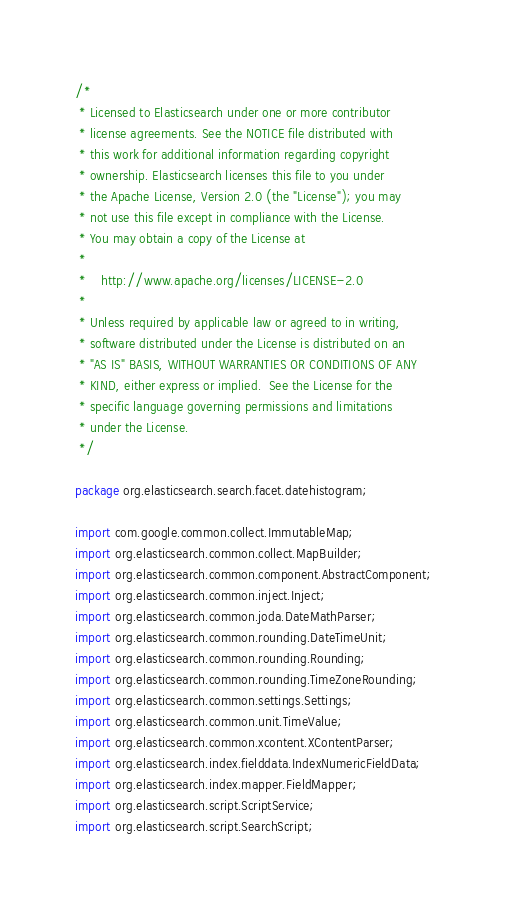Convert code to text. <code><loc_0><loc_0><loc_500><loc_500><_Java_>/*
 * Licensed to Elasticsearch under one or more contributor
 * license agreements. See the NOTICE file distributed with
 * this work for additional information regarding copyright
 * ownership. Elasticsearch licenses this file to you under
 * the Apache License, Version 2.0 (the "License"); you may
 * not use this file except in compliance with the License.
 * You may obtain a copy of the License at
 *
 *    http://www.apache.org/licenses/LICENSE-2.0
 *
 * Unless required by applicable law or agreed to in writing,
 * software distributed under the License is distributed on an
 * "AS IS" BASIS, WITHOUT WARRANTIES OR CONDITIONS OF ANY
 * KIND, either express or implied.  See the License for the
 * specific language governing permissions and limitations
 * under the License.
 */

package org.elasticsearch.search.facet.datehistogram;

import com.google.common.collect.ImmutableMap;
import org.elasticsearch.common.collect.MapBuilder;
import org.elasticsearch.common.component.AbstractComponent;
import org.elasticsearch.common.inject.Inject;
import org.elasticsearch.common.joda.DateMathParser;
import org.elasticsearch.common.rounding.DateTimeUnit;
import org.elasticsearch.common.rounding.Rounding;
import org.elasticsearch.common.rounding.TimeZoneRounding;
import org.elasticsearch.common.settings.Settings;
import org.elasticsearch.common.unit.TimeValue;
import org.elasticsearch.common.xcontent.XContentParser;
import org.elasticsearch.index.fielddata.IndexNumericFieldData;
import org.elasticsearch.index.mapper.FieldMapper;
import org.elasticsearch.script.ScriptService;
import org.elasticsearch.script.SearchScript;</code> 